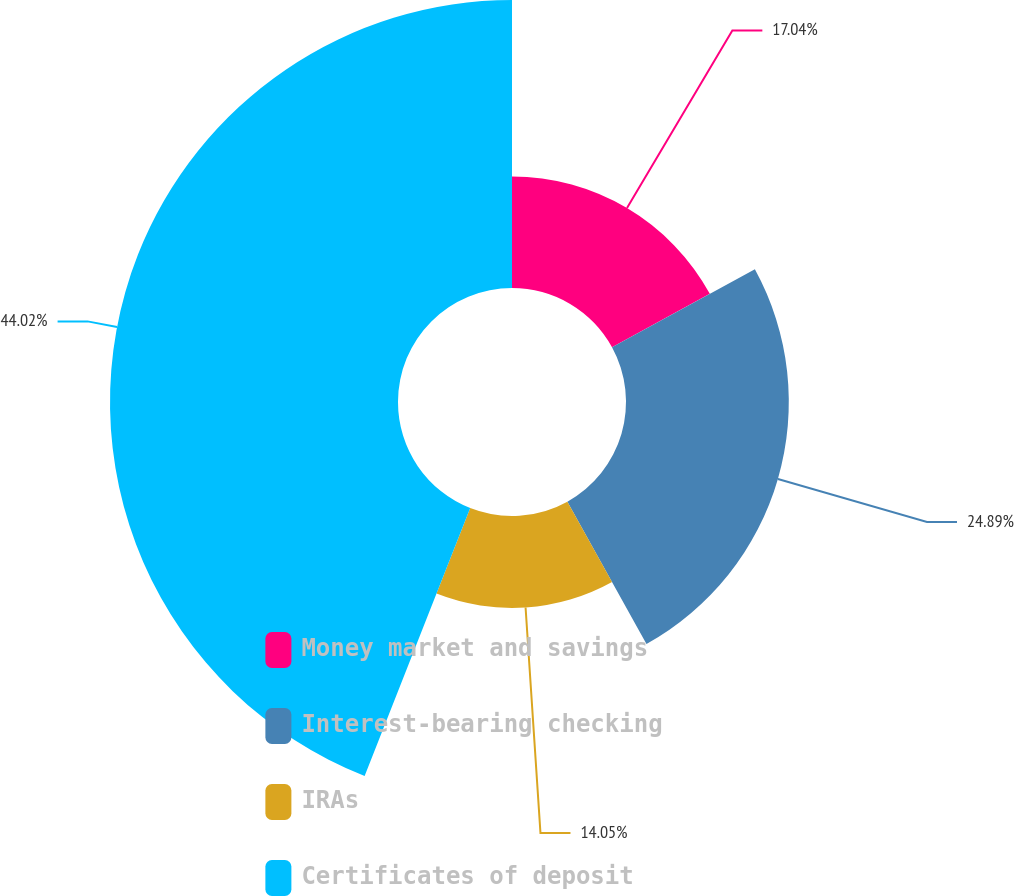Convert chart to OTSL. <chart><loc_0><loc_0><loc_500><loc_500><pie_chart><fcel>Money market and savings<fcel>Interest-bearing checking<fcel>IRAs<fcel>Certificates of deposit<nl><fcel>17.04%<fcel>24.89%<fcel>14.05%<fcel>44.03%<nl></chart> 